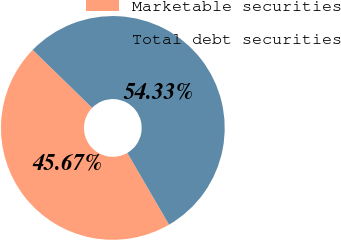Convert chart to OTSL. <chart><loc_0><loc_0><loc_500><loc_500><pie_chart><fcel>Marketable securities<fcel>Total debt securities<nl><fcel>45.67%<fcel>54.33%<nl></chart> 